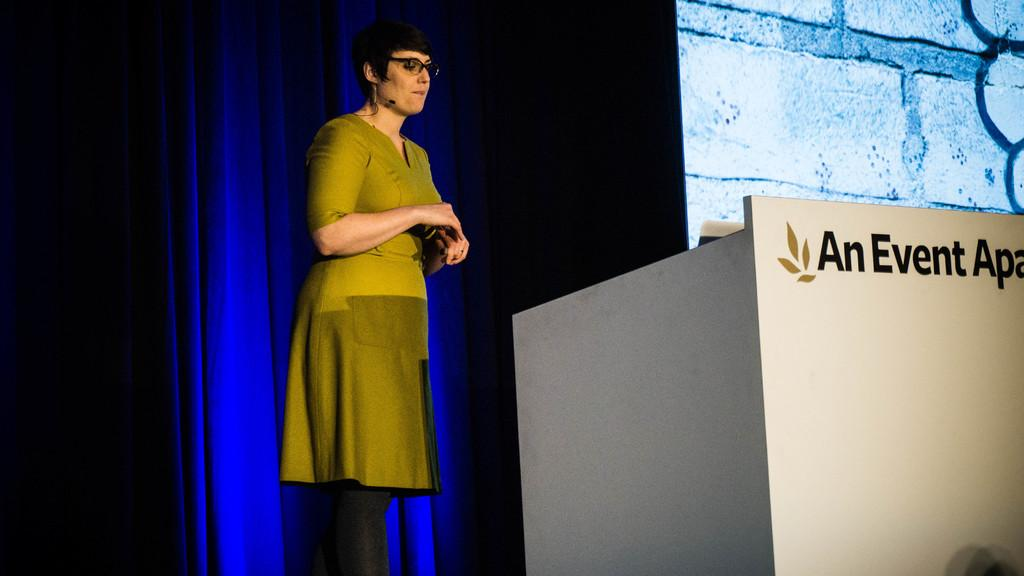What is the main subject in the image? There is a person standing in the image. What can be seen in the background of the image? There is a curtain in the image. What object is present near the person? There is a screen in the image. What might the person be using the screen for? The person might be using the screen for presenting or displaying information. What other object is present in the image? There is a podium in the image. What time of day is it in the image, considering the presence of an owl? There is no owl present in the image, so it is not possible to determine the time of day based on that information. 